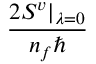<formula> <loc_0><loc_0><loc_500><loc_500>\frac { 2 S ^ { v } | _ { \lambda = 0 } } { n _ { f } }</formula> 